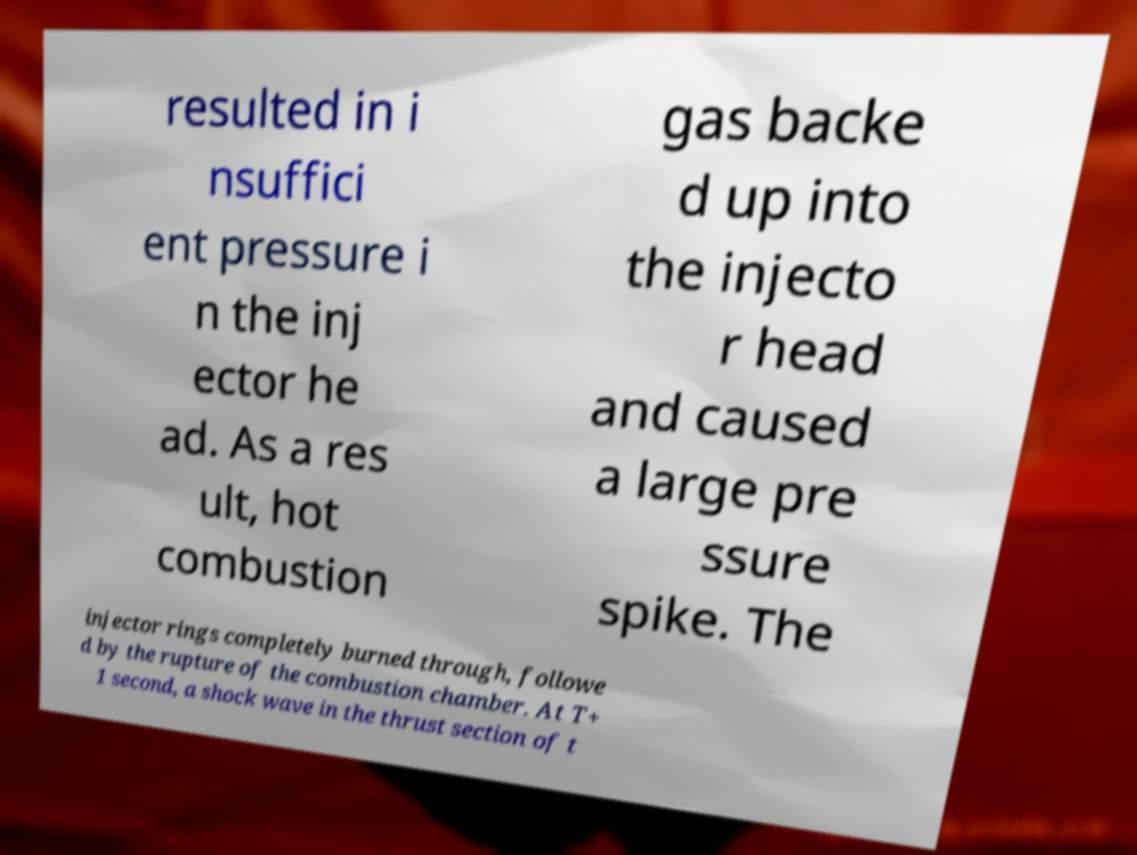Could you assist in decoding the text presented in this image and type it out clearly? resulted in i nsuffici ent pressure i n the inj ector he ad. As a res ult, hot combustion gas backe d up into the injecto r head and caused a large pre ssure spike. The injector rings completely burned through, followe d by the rupture of the combustion chamber. At T+ 1 second, a shock wave in the thrust section of t 